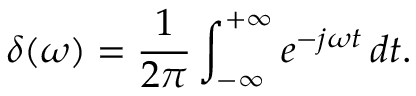Convert formula to latex. <formula><loc_0><loc_0><loc_500><loc_500>\delta ( \omega ) = \frac { 1 } { 2 \pi } \int _ { - \infty } ^ { + \infty } e ^ { - j \omega t } \, d t .</formula> 